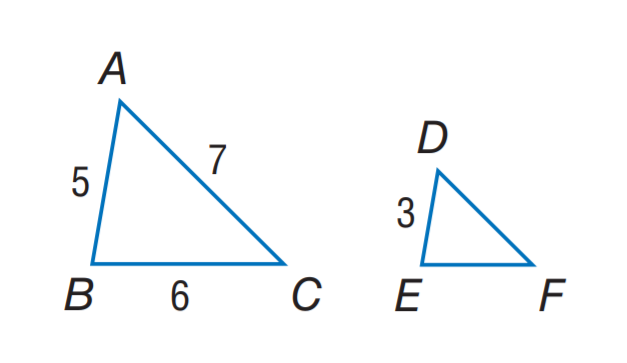Question: Find the perimeter of the \triangle D E F, if \triangle A B C \sim \triangle D E F, A B = 5, B C = 6, A C = 7, and D E = 3.
Choices:
A. 6
B. 10.2
C. 10.8
D. 13
Answer with the letter. Answer: C 